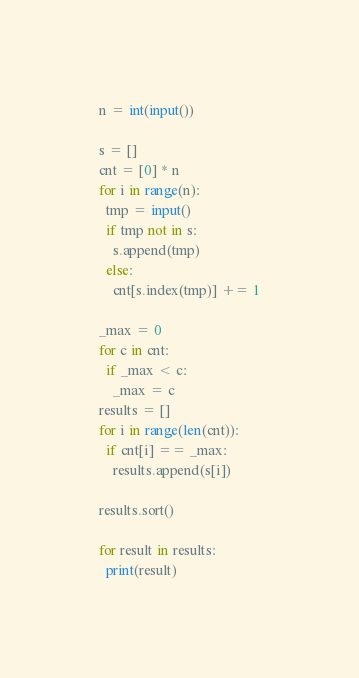Convert code to text. <code><loc_0><loc_0><loc_500><loc_500><_Python_>n = int(input())

s = []
cnt = [0] * n
for i in range(n):
  tmp = input()
  if tmp not in s:
    s.append(tmp)
  else:
    cnt[s.index(tmp)] += 1

_max = 0
for c in cnt:
  if _max < c:
    _max = c
results = []
for i in range(len(cnt)):
  if cnt[i] == _max:
    results.append(s[i])

results.sort()

for result in results:
  print(result)</code> 